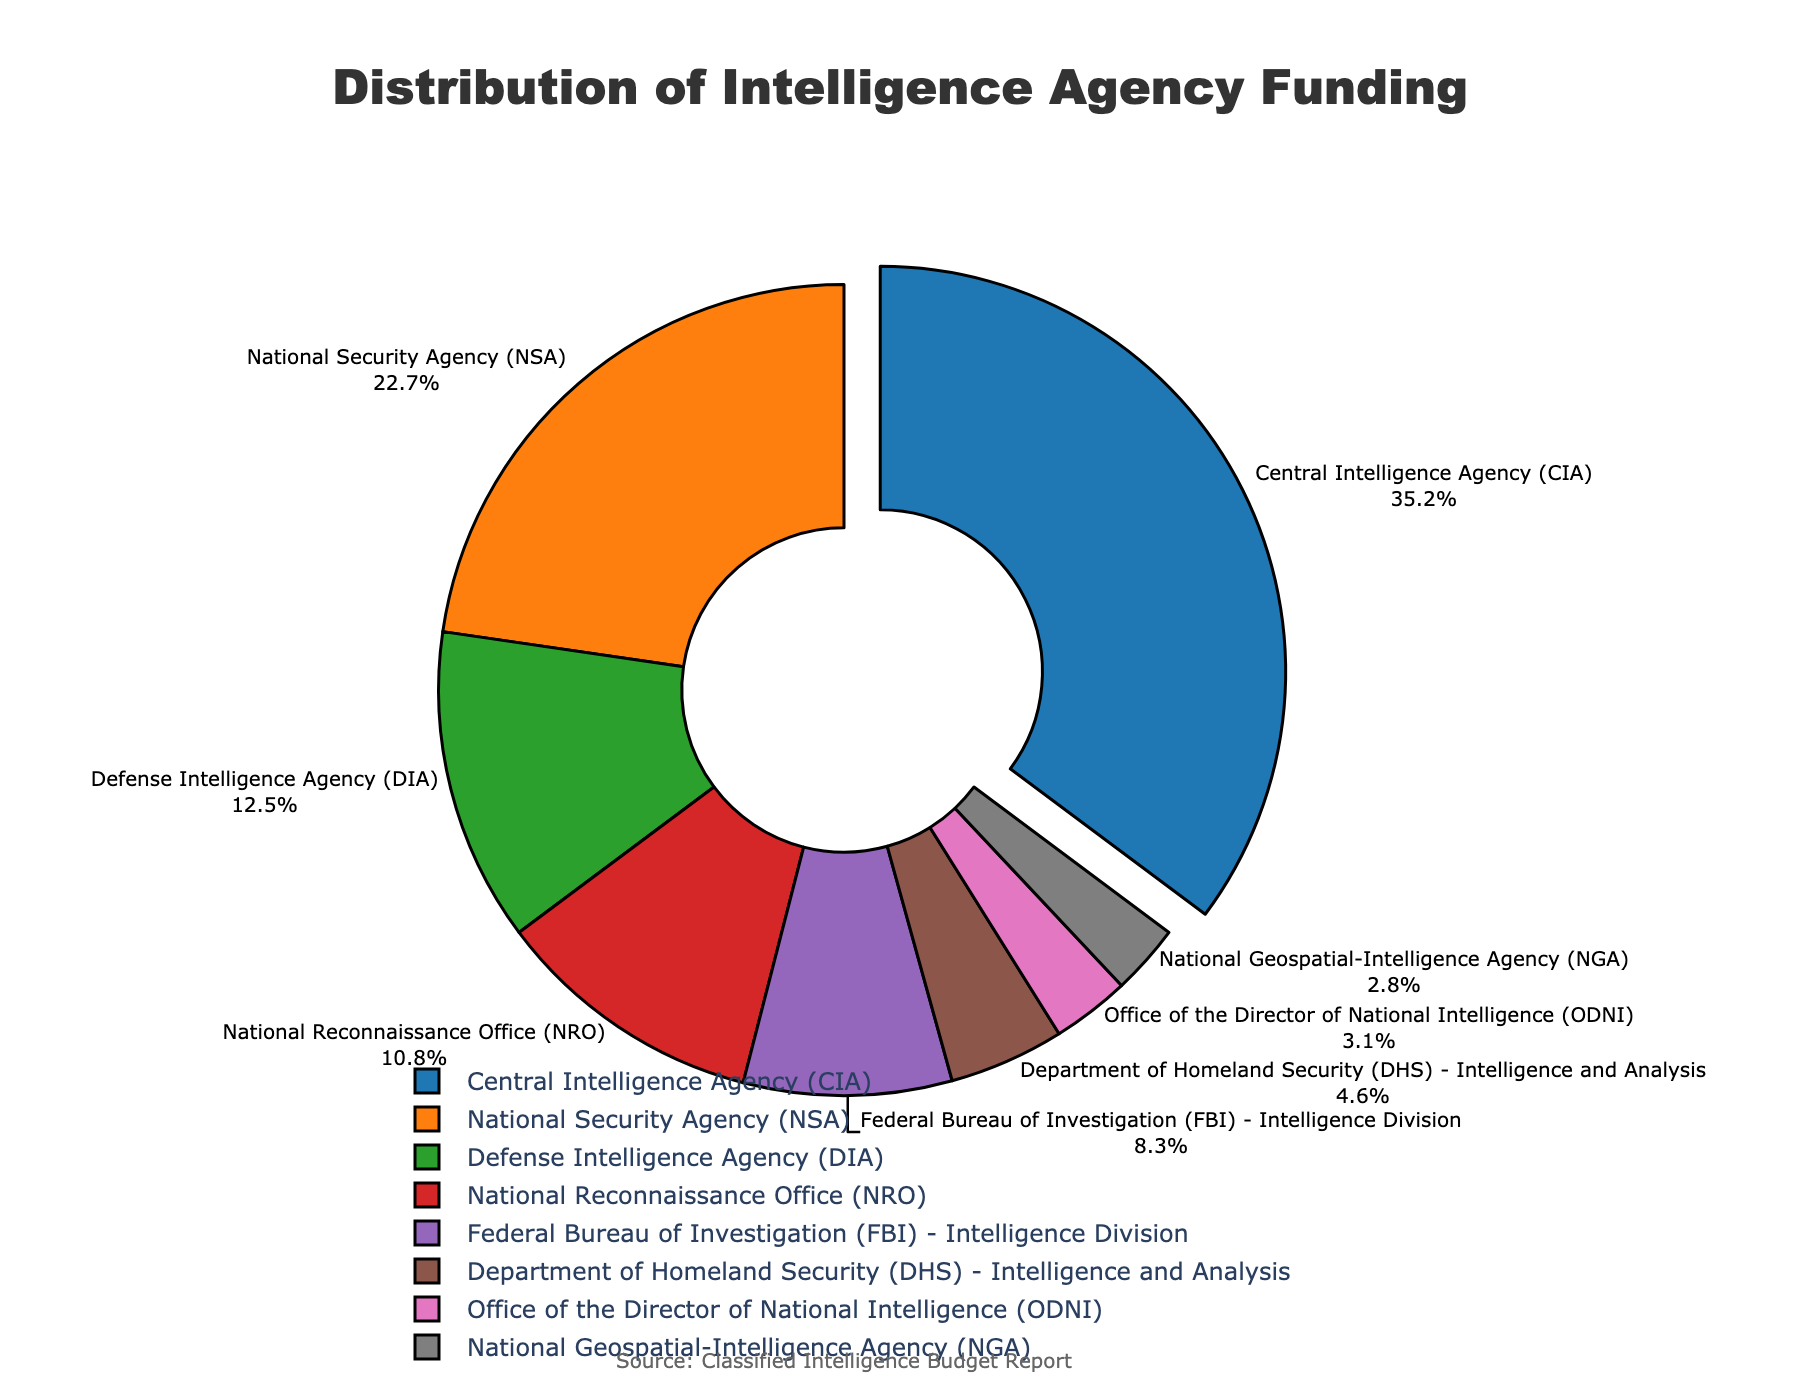Which department receives the highest percentage of funding? The department with the largest slice of the pie chart is the Central Intelligence Agency (CIA), with a percentage of 35.2%.
Answer: Central Intelligence Agency (CIA) Which department receives the least percentage of funding? The smallest slice of the pie chart corresponds to the National Geospatial-Intelligence Agency (NGA), with a percentage of 2.8%.
Answer: National Geospatial-Intelligence Agency (NGA) What is the combined funding percentage for the FBI and DHS? To find the combined percentage, sum the individual percentages for the FBI (8.3%) and DHS (4.6%): 8.3 + 4.6 = 12.9%.
Answer: 12.9% How does the funding percentage for the NSA compare to that of the NRO? The NSA's funding percentage is 22.7%, and the NRO's is 10.8%. Comparing these, the NSA's funding is greater than the NRO's.
Answer: NSA funding is greater Which departments have a funding percentage greater than 10%? The departments with funding percentages greater than 10% are the CIA (35.2%), NSA (22.7%), and DIA (12.5%).
Answer: CIA, NSA, DIA How much more funding percentage does the CIA receive compared to the DIA? Subtract the DIA's percentage (12.5%) from the CIA's percentage (35.2%): 35.2 - 12.5 = 22.7%.
Answer: 22.7% What percentage of funding is allocated to intelligence agencies other than the CIA? Subtract the CIA's percentage (35.2%) from 100%: 100 - 35.2 = 64.8%.
Answer: 64.8% What is the average funding percentage of the NRO, DHS, ODNI, and NGA? Sum the percentages: 10.8 (NRO) + 4.6 (DHS) + 3.1 (ODNI) + 2.8 (NGA) = 21.3%. Then divide by the number of departments (4): 21.3 / 4 = 5.325%.
Answer: 5.325% Which department’s funding percentage is highlighted in the pie chart? The pie chart has a pulled-out slice that highlights the Central Intelligence Agency (CIA) with a 35.2% funding percentage.
Answer: Central Intelligence Agency (CIA) How much more funding does the FBI's Intelligence Division receive compared to the National Geospatial-Intelligence Agency (NGA)? Subtract the NGA's percentage (2.8%) from the FBI's percentage (8.3%): 8.3 - 2.8 = 5.5%.
Answer: 5.5% 